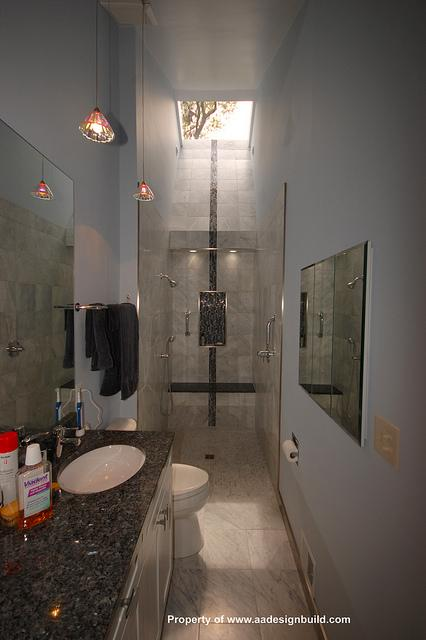What color is the fluid in the small container with the white cap on the top? orange 